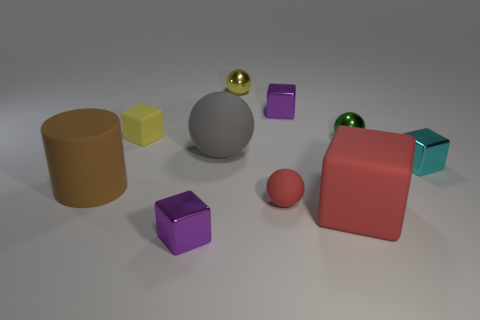Subtract all gray cubes. Subtract all blue cylinders. How many cubes are left? 5 Subtract all cylinders. How many objects are left? 9 Add 7 cyan objects. How many cyan objects are left? 8 Add 3 small blue things. How many small blue things exist? 3 Subtract 0 purple balls. How many objects are left? 10 Subtract all yellow blocks. Subtract all tiny shiny blocks. How many objects are left? 6 